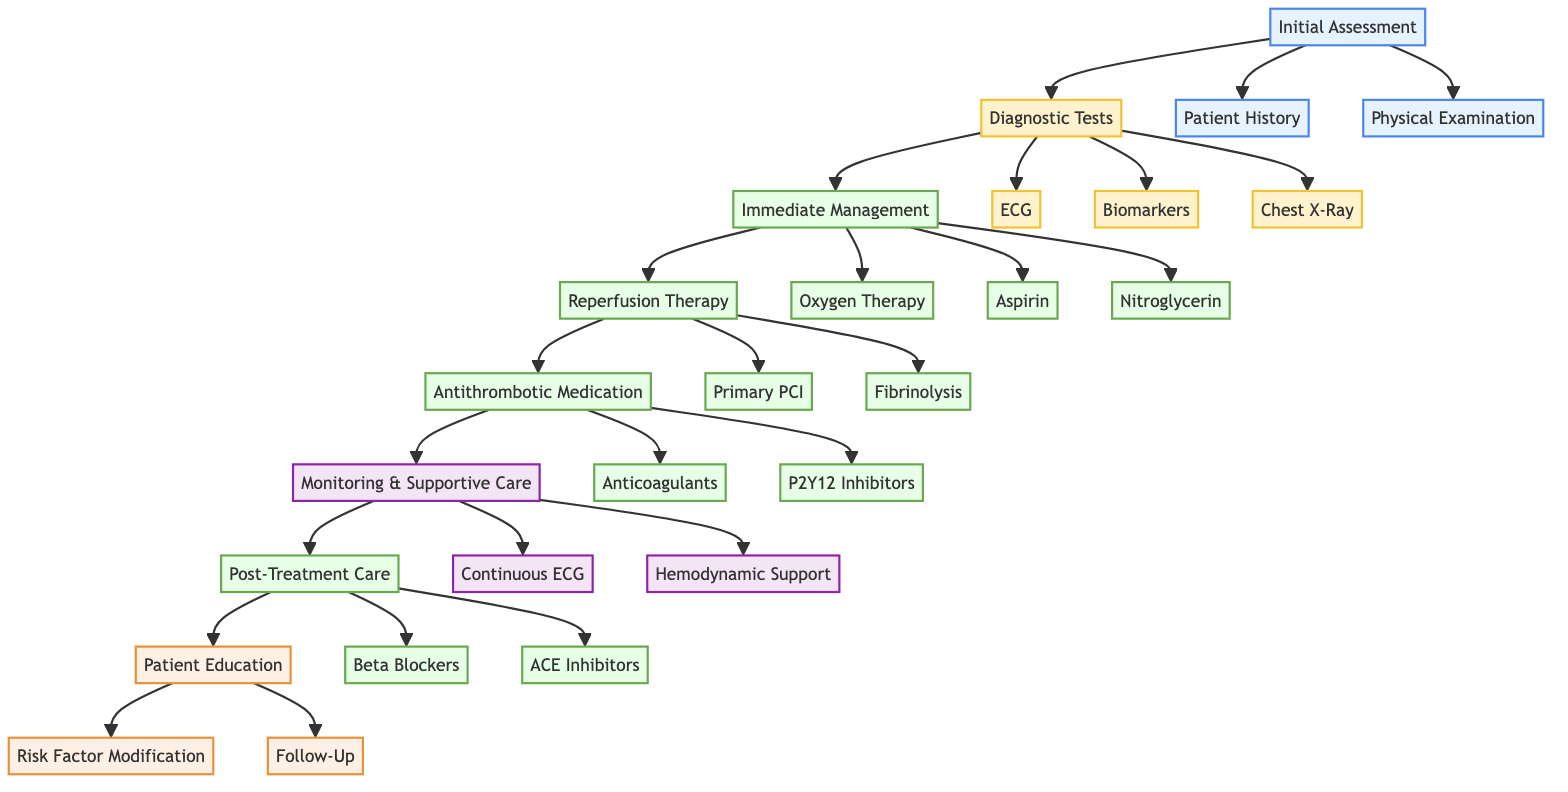What is the first step in the clinical pathway? The diagram indicates that the first step in the clinical pathway is "Initial Assessment," which follows directly after the start of the pathway.
Answer: Initial Assessment How many diagnostic tests are listed in the pathway? The diagram shows three diagnostic tests: ECG, Biomarkers, and Chest X-Ray, as identified by counting the nodes connected to the "Diagnostic Tests" box.
Answer: 3 What type of management is oxygen therapy categorized under? Oxygen therapy is under the "Immediate Management" section of the diagram, as it is listed as the first intervention following the initial assessment and diagnostic tests.
Answer: Immediate Management What must be administered within 30 minutes if PCI is not available? The diagram specifies that if PCI is not available within 120 minutes, "Fibrinolysis" must be administered within 30 minutes, clearly indicating the timing requirement for this treatment.
Answer: Fibrinolysis What is indicated for post-treatment care regarding blood pressure? The diagram suggests administering "Beta Blockers" within 24 hours as a part of post-treatment care, with the purpose of reducing myocardial oxygen demand, which relates to blood pressure management.
Answer: Beta Blockers What follows after the "Immediate Management" phase in the pathway? The diagram shows that after the "Immediate Management" phase, the next phase is "Reperfusion Therapy," following the flow of treatment nodes interconnected in the pathway.
Answer: Reperfusion Therapy Which medications are listed under antithrombotic medication? The “Antithrombotic Medication” section includes "Anticoagulants" and "P2Y12 Inhibitors," both of which are connected to the relevant node in the pathway diagram.
Answer: Anticoagulants, P2Y12 Inhibitors How many components are there in the "Patient Education" section? The "Patient Education" section contains two components: "Risk Factor Modification" and "Follow-Up," which can be identified by counting the nodes in that section of the diagram.
Answer: 2 What type of monitoring is continuous ECG associated with? Continuous ECG is associated with "Monitoring & Supportive Care," as indicated in the diagram where it connects with this section for ongoing observation of cardiac rhythm.
Answer: Monitoring & Supportive Care 